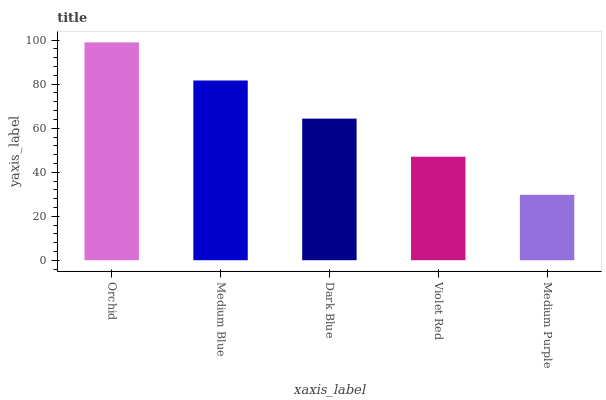Is Medium Purple the minimum?
Answer yes or no. Yes. Is Orchid the maximum?
Answer yes or no. Yes. Is Medium Blue the minimum?
Answer yes or no. No. Is Medium Blue the maximum?
Answer yes or no. No. Is Orchid greater than Medium Blue?
Answer yes or no. Yes. Is Medium Blue less than Orchid?
Answer yes or no. Yes. Is Medium Blue greater than Orchid?
Answer yes or no. No. Is Orchid less than Medium Blue?
Answer yes or no. No. Is Dark Blue the high median?
Answer yes or no. Yes. Is Dark Blue the low median?
Answer yes or no. Yes. Is Orchid the high median?
Answer yes or no. No. Is Medium Purple the low median?
Answer yes or no. No. 